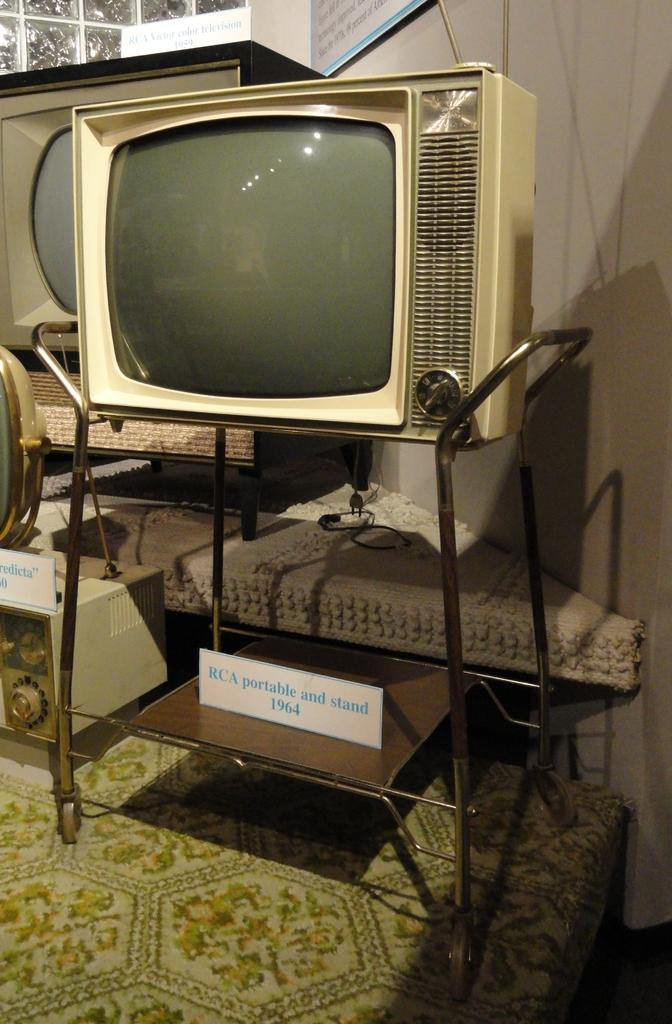Provide a one-sentence caption for the provided image. 1964 Television and portable television stand with other antique televisions and radios in the background. 